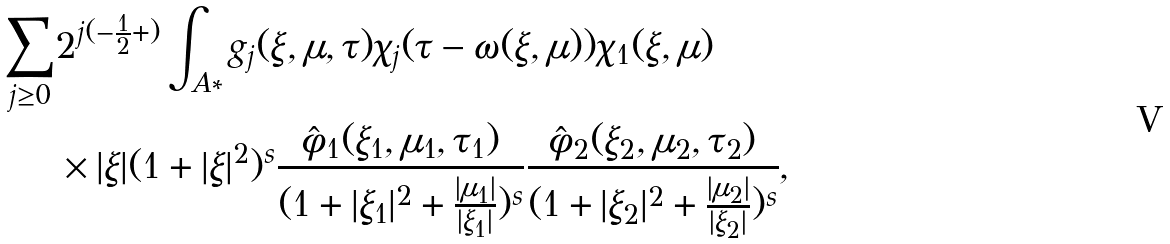<formula> <loc_0><loc_0><loc_500><loc_500>\sum _ { j \geq 0 } & 2 ^ { j ( - \frac { 1 } { 2 } + ) } \int _ { A * } g _ { j } ( \xi , \mu , \tau ) \chi _ { j } ( \tau - \omega ( \xi , \mu ) ) \chi _ { 1 } ( \xi , \mu ) \\ & \times | \xi | ( 1 + | \xi | ^ { 2 } ) ^ { s } \frac { \hat { \phi } _ { 1 } ( \xi _ { 1 } , \mu _ { 1 } , \tau _ { 1 } ) } { ( 1 + | \xi _ { 1 } | ^ { 2 } + \frac { | \mu _ { 1 } | } { | \xi _ { 1 } | } ) ^ { s } } \frac { \hat { \phi } _ { 2 } ( \xi _ { 2 } , \mu _ { 2 } , \tau _ { 2 } ) } { ( 1 + | \xi _ { 2 } | ^ { 2 } + \frac { | \mu _ { 2 } | } { | \xi _ { 2 } | } ) ^ { s } } ,</formula> 